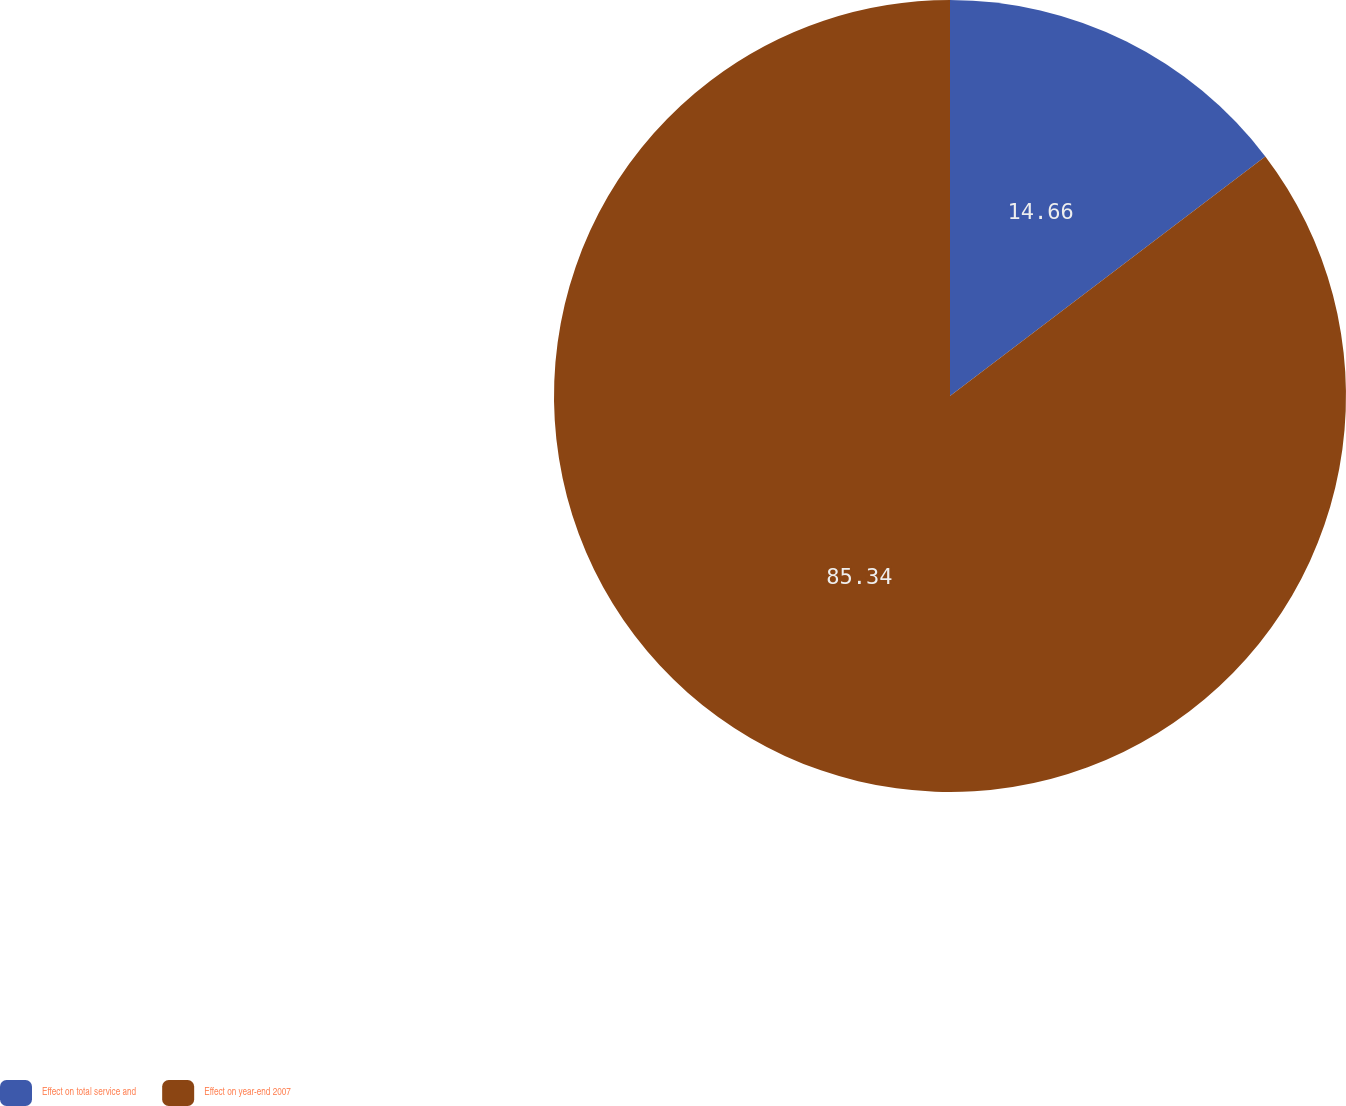Convert chart to OTSL. <chart><loc_0><loc_0><loc_500><loc_500><pie_chart><fcel>Effect on total service and<fcel>Effect on year-end 2007<nl><fcel>14.66%<fcel>85.34%<nl></chart> 